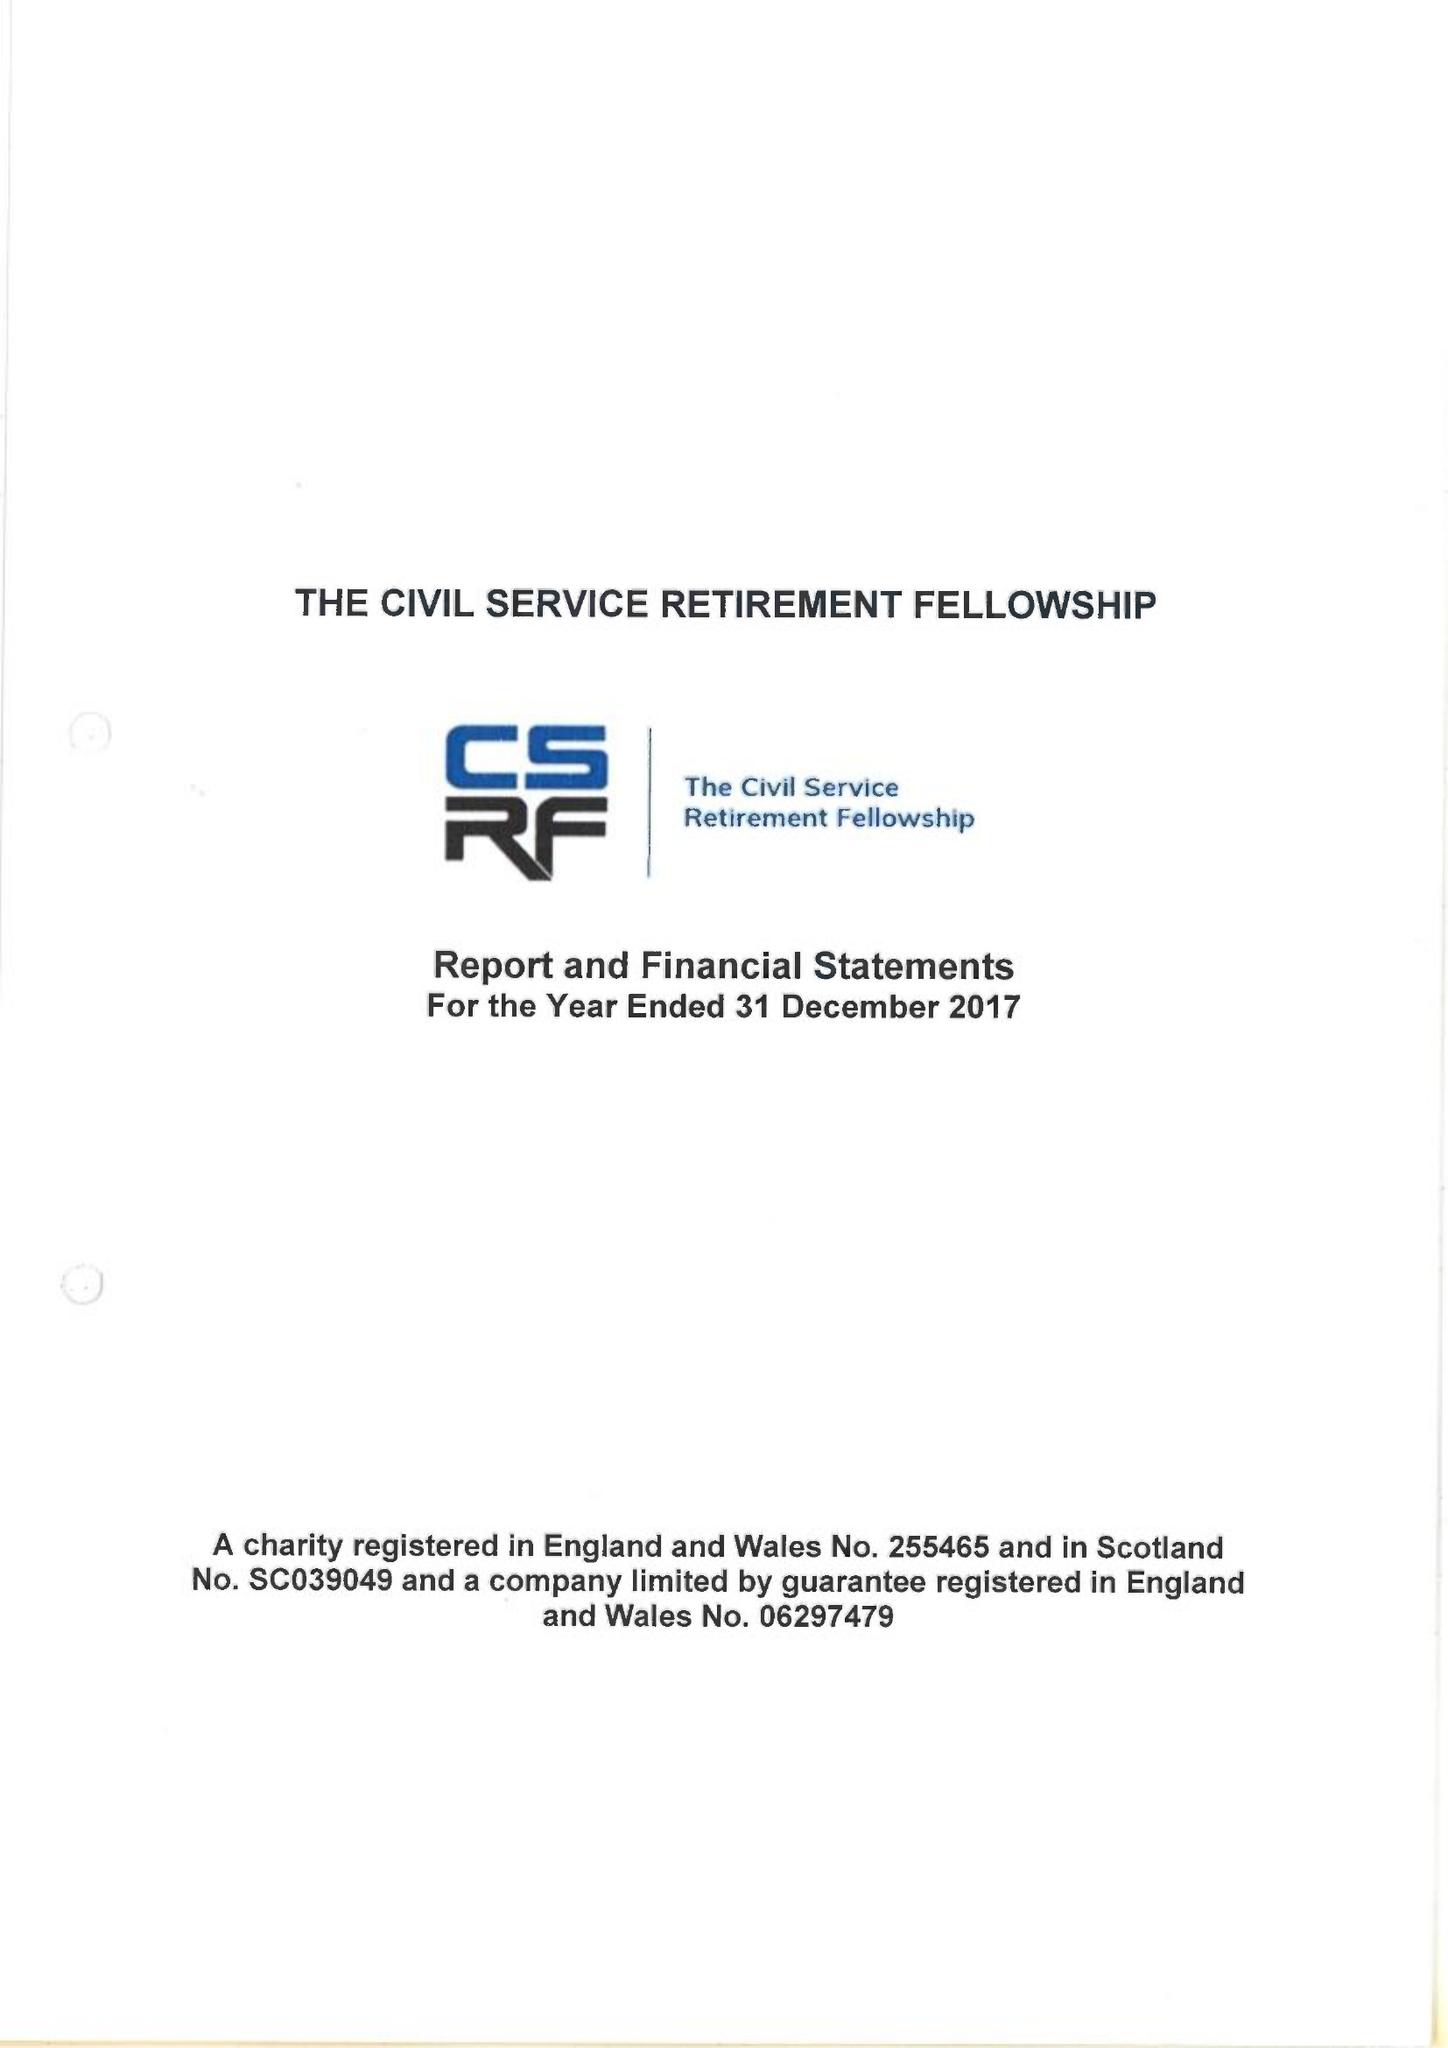What is the value for the report_date?
Answer the question using a single word or phrase. 2017-12-31 